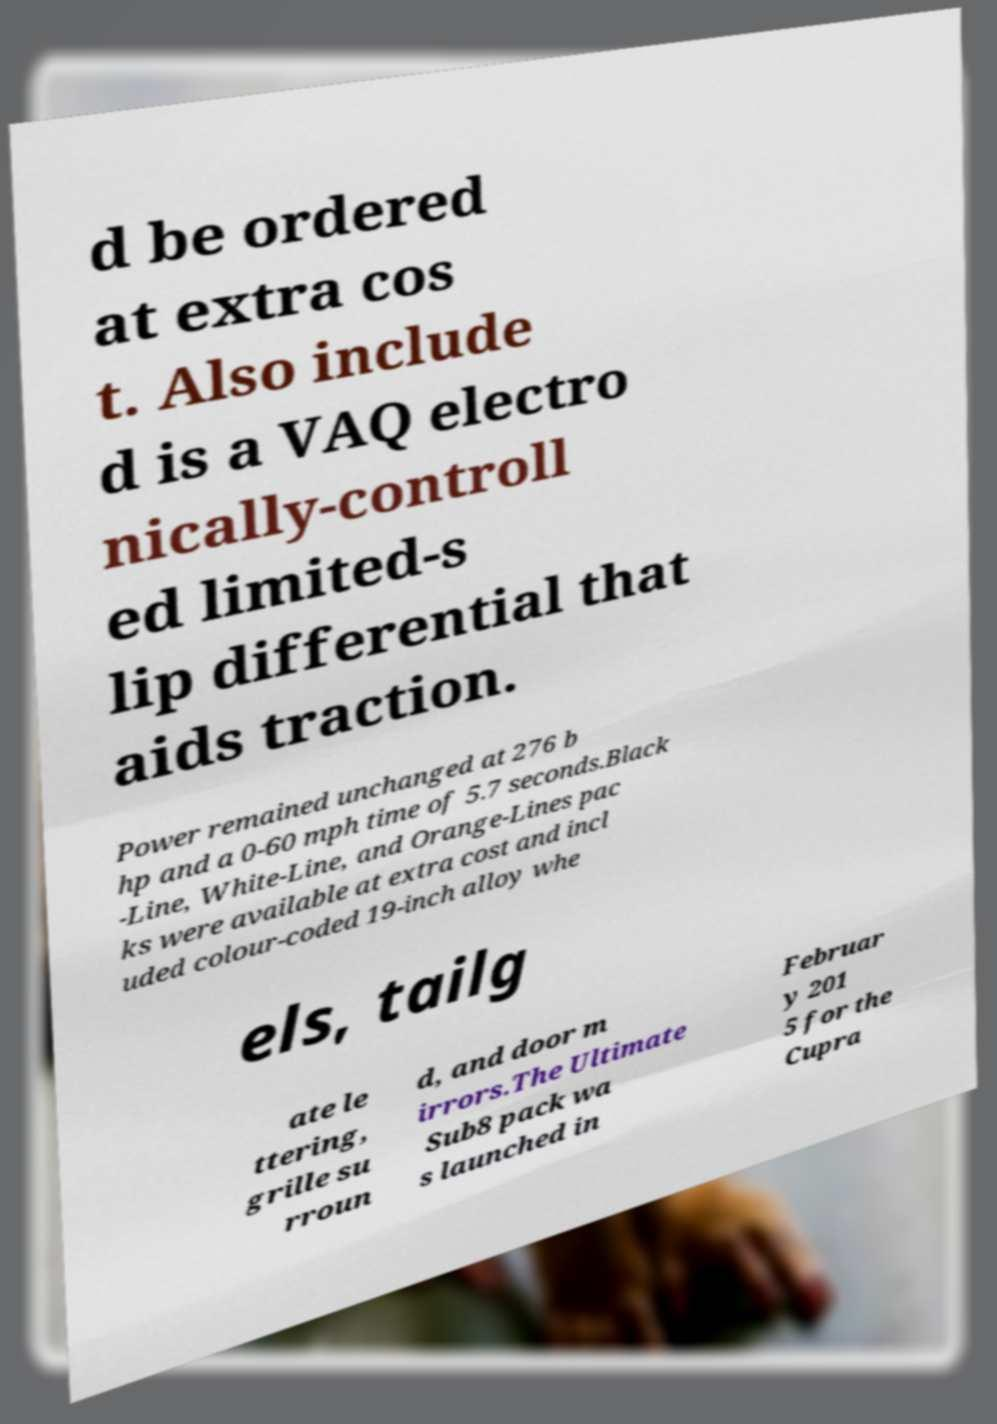For documentation purposes, I need the text within this image transcribed. Could you provide that? d be ordered at extra cos t. Also include d is a VAQ electro nically-controll ed limited-s lip differential that aids traction. Power remained unchanged at 276 b hp and a 0-60 mph time of 5.7 seconds.Black -Line, White-Line, and Orange-Lines pac ks were available at extra cost and incl uded colour-coded 19-inch alloy whe els, tailg ate le ttering, grille su rroun d, and door m irrors.The Ultimate Sub8 pack wa s launched in Februar y 201 5 for the Cupra 